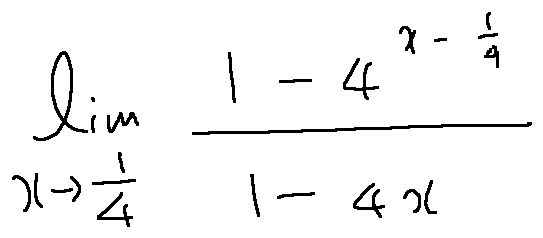Convert formula to latex. <formula><loc_0><loc_0><loc_500><loc_500>\lim \lim i t s _ { x \rightarrow \frac { 1 } { 4 } } \frac { 1 - 4 ^ { x - \frac { 1 } { 4 } } } { 1 - 4 x }</formula> 